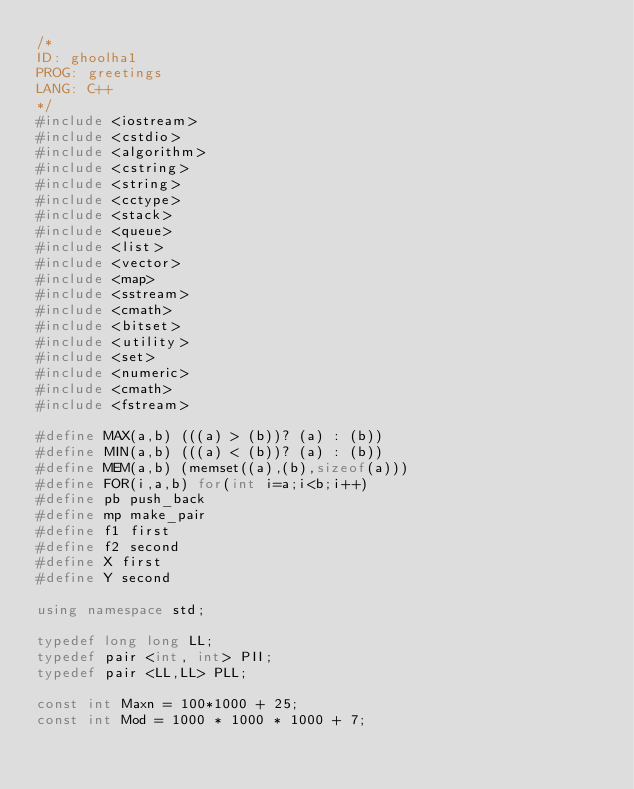Convert code to text. <code><loc_0><loc_0><loc_500><loc_500><_C++_>/*
ID: ghoolha1
PROG: greetings
LANG: C++
*/
#include <iostream>
#include <cstdio>
#include <algorithm>
#include <cstring>
#include <string>
#include <cctype>
#include <stack>
#include <queue>
#include <list>
#include <vector>
#include <map>
#include <sstream>
#include <cmath>
#include <bitset>
#include <utility>
#include <set>
#include <numeric>
#include <cmath>
#include <fstream>

#define MAX(a,b) (((a) > (b))? (a) : (b))
#define MIN(a,b) (((a) < (b))? (a) : (b))
#define MEM(a,b) (memset((a),(b),sizeof(a)))
#define FOR(i,a,b) for(int i=a;i<b;i++)
#define pb push_back
#define mp make_pair
#define f1 first
#define f2 second
#define X first
#define Y second

using namespace std;

typedef long long LL;
typedef pair <int, int> PII;
typedef pair <LL,LL> PLL;

const int Maxn = 100*1000 + 25;
const int Mod = 1000 * 1000 * 1000 + 7;
</code> 